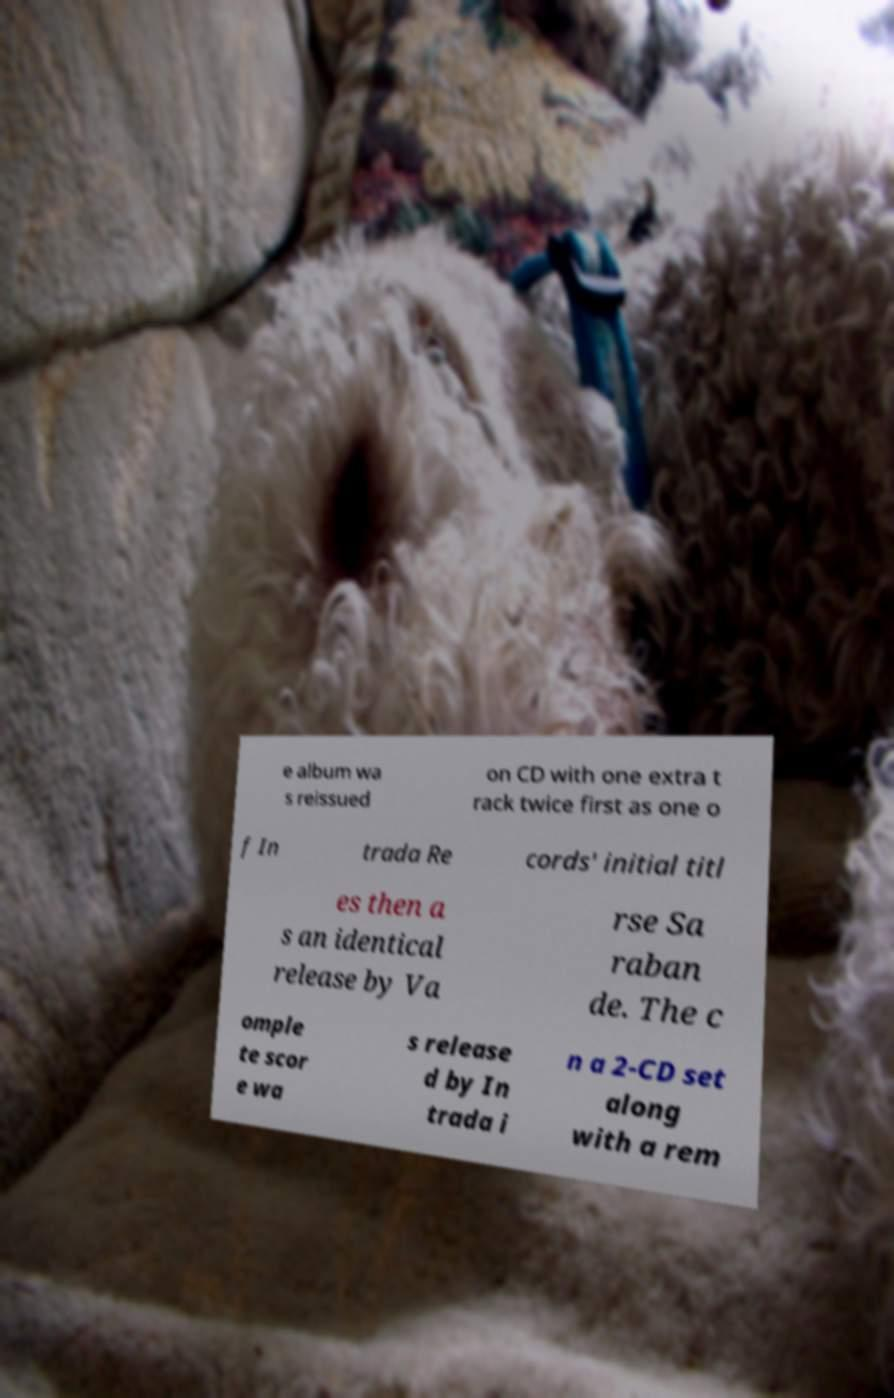What messages or text are displayed in this image? I need them in a readable, typed format. e album wa s reissued on CD with one extra t rack twice first as one o f In trada Re cords' initial titl es then a s an identical release by Va rse Sa raban de. The c omple te scor e wa s release d by In trada i n a 2-CD set along with a rem 